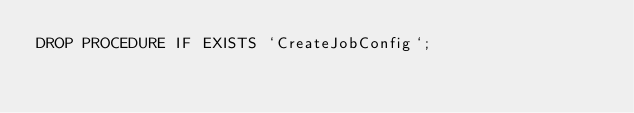Convert code to text. <code><loc_0><loc_0><loc_500><loc_500><_SQL_>DROP PROCEDURE IF EXISTS `CreateJobConfig`;
</code> 